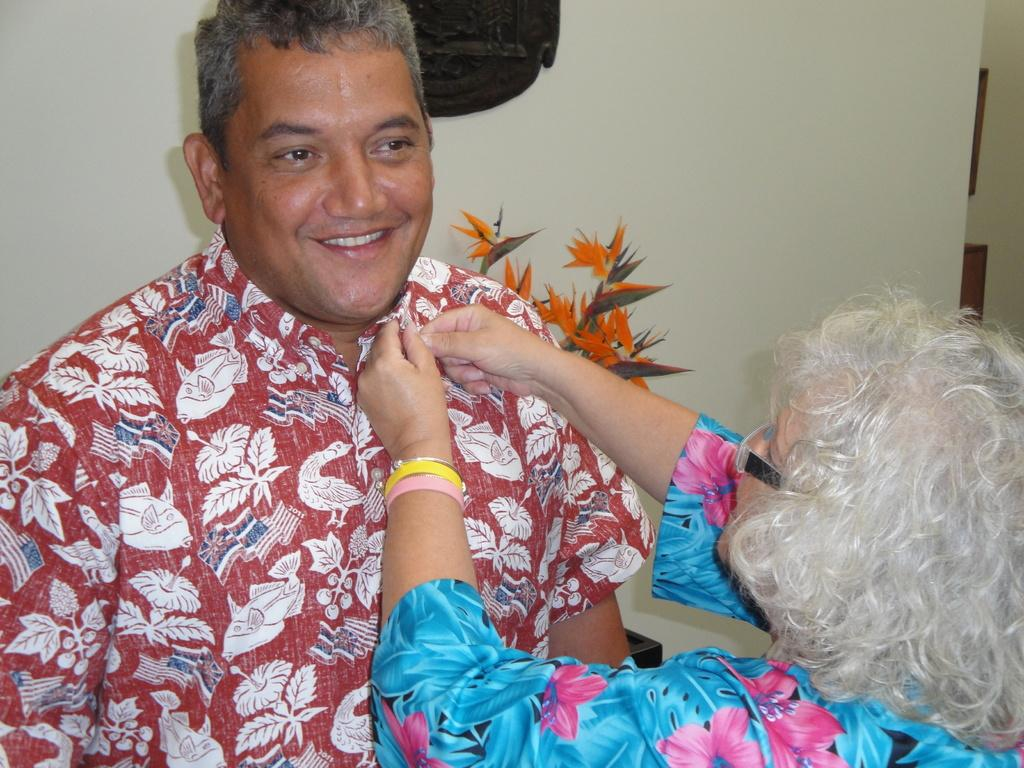How many people are present in the image? There are two people in the image. Can you describe one of the people in the image? One of the people is wearing glasses. What can be seen in the background of the image? There is a houseplant and objects on the wall in the background of the image. Can you tell me how many dogs are visible in the image? There are no dogs present in the image. Is there a drain visible in the image? There is no drain present in the image. 